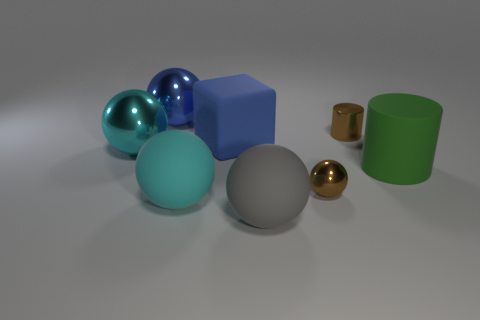How many metal objects are tiny red balls or small brown objects?
Ensure brevity in your answer.  2. There is a large object right of the large gray sphere; is it the same shape as the blue thing that is in front of the blue metal thing?
Give a very brief answer. No. Is there a red object made of the same material as the green cylinder?
Make the answer very short. No. What is the color of the big cube?
Give a very brief answer. Blue. What is the size of the brown metal thing that is behind the small sphere?
Make the answer very short. Small. What number of big metallic objects have the same color as the tiny cylinder?
Offer a terse response. 0. Is there a gray sphere behind the big object left of the blue sphere?
Provide a short and direct response. No. Does the big object to the right of the gray matte sphere have the same color as the tiny thing on the left side of the tiny brown cylinder?
Give a very brief answer. No. There is a cube that is the same size as the green cylinder; what is its color?
Offer a terse response. Blue. Are there the same number of metal things behind the cyan metal thing and tiny brown balls that are in front of the brown metal ball?
Offer a terse response. No. 